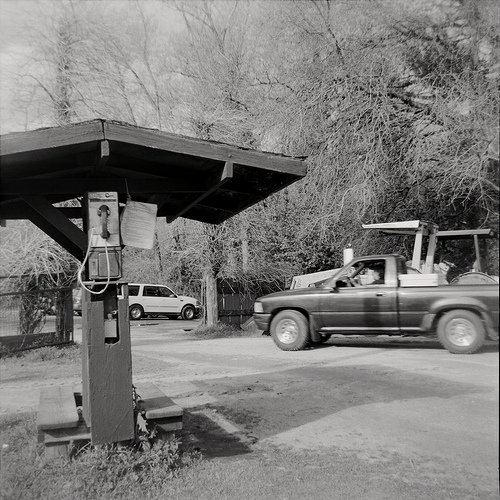Please provide the bounding box coordinate of the region this sentence describes: A small wooden awning. The bounding box for the small wooden awning is at coordinates [0.0, 0.24, 0.61, 0.46]. This captures the entire wooden awning structure covering the pay phone area. 